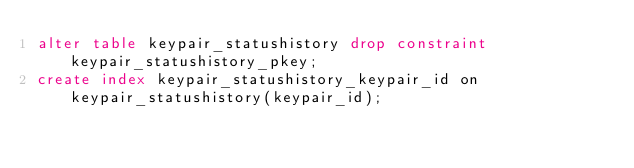<code> <loc_0><loc_0><loc_500><loc_500><_SQL_>alter table keypair_statushistory drop constraint keypair_statushistory_pkey;
create index keypair_statushistory_keypair_id on keypair_statushistory(keypair_id);</code> 